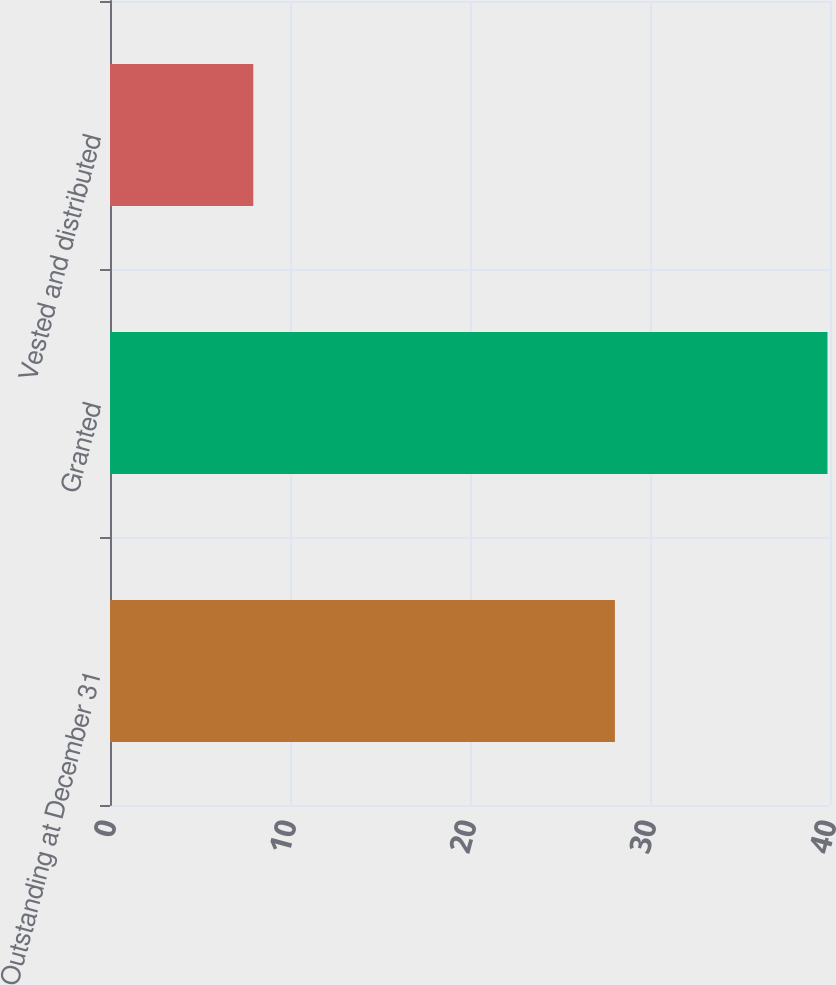<chart> <loc_0><loc_0><loc_500><loc_500><bar_chart><fcel>Outstanding at December 31<fcel>Granted<fcel>Vested and distributed<nl><fcel>28.05<fcel>39.86<fcel>7.96<nl></chart> 